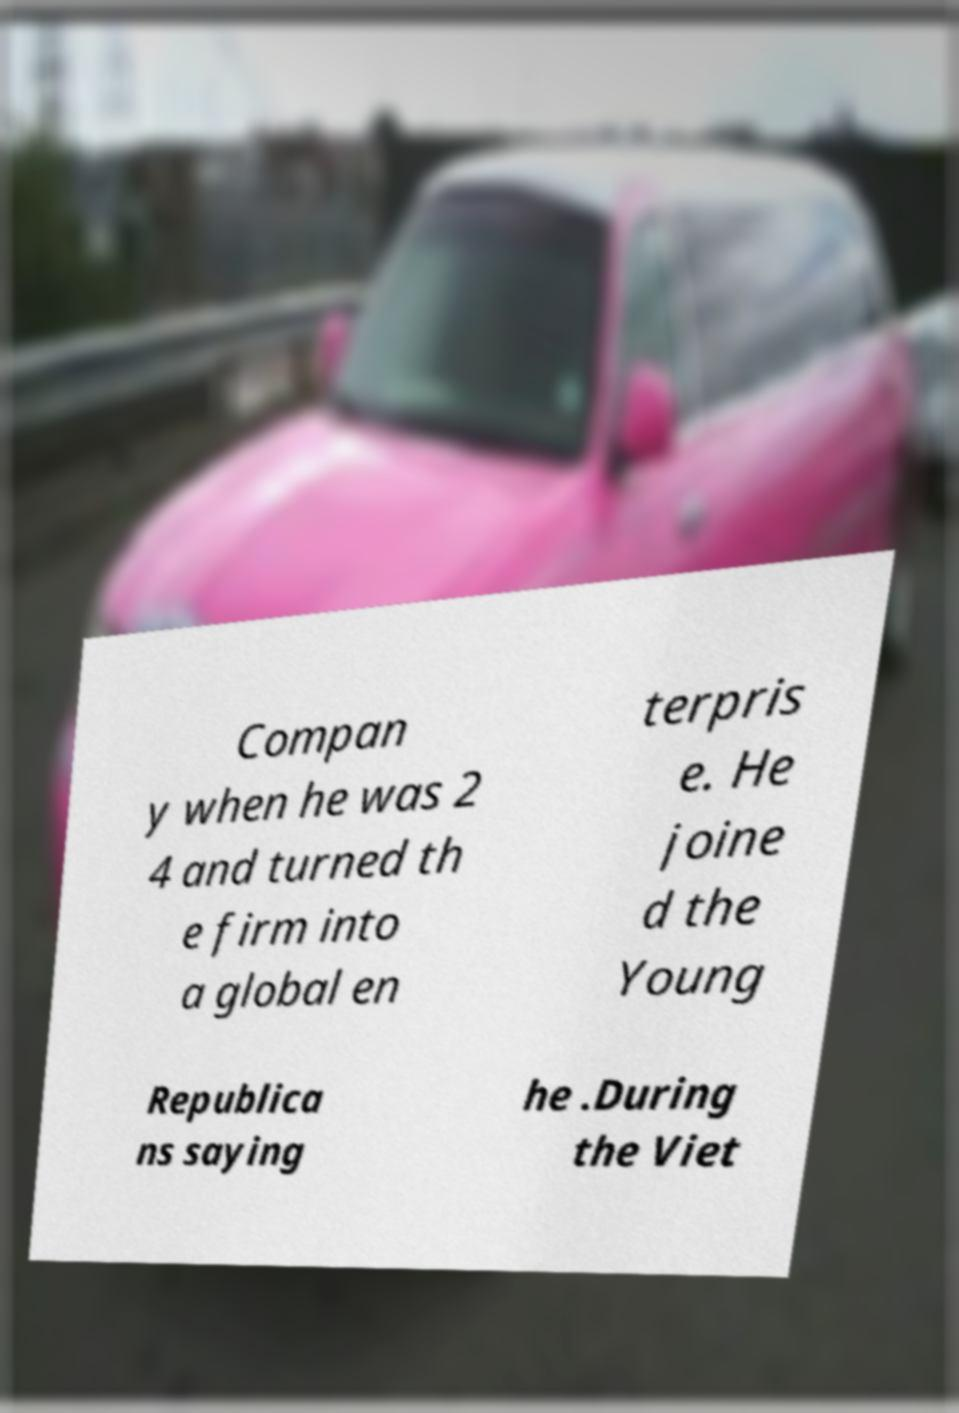What messages or text are displayed in this image? I need them in a readable, typed format. Compan y when he was 2 4 and turned th e firm into a global en terpris e. He joine d the Young Republica ns saying he .During the Viet 